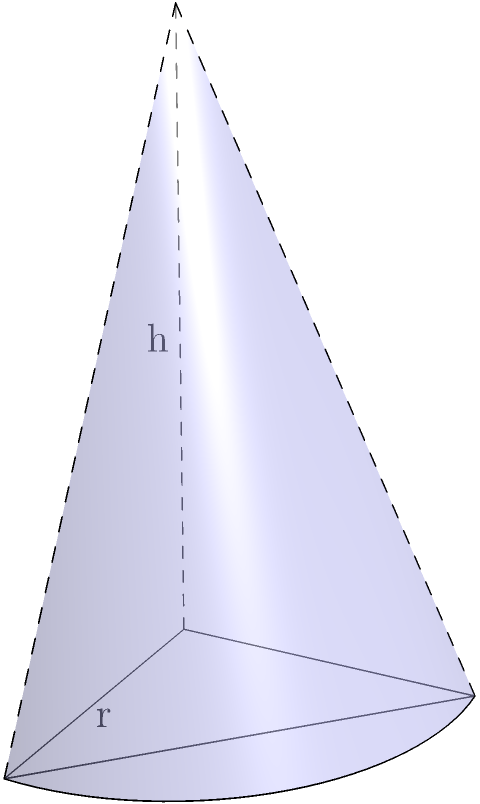As a first responder, you're tasked with determining the volume of a cone-shaped warning beacon. The beacon has a radius (r) of 2 meters at its base and a height (h) of 4 meters. Calculate the volume of this warning beacon in cubic meters. To calculate the volume of a cone, we use the formula:

$$V = \frac{1}{3}\pi r^2 h$$

Where:
$V$ = volume
$r$ = radius of the base
$h$ = height of the cone

Given:
$r = 2$ meters
$h = 4$ meters

Let's substitute these values into the formula:

$$V = \frac{1}{3}\pi (2)^2 (4)$$

$$V = \frac{1}{3}\pi (4) (4)$$

$$V = \frac{16\pi}{3}$$

$$V \approx 16.76 \text{ cubic meters}$$

As first responders, we often round to the nearest whole number for practical purposes, so we can say the volume is approximately 17 cubic meters.
Answer: $\frac{16\pi}{3}$ cubic meters (or approximately 17 cubic meters) 